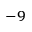<formula> <loc_0><loc_0><loc_500><loc_500>^ { - 9 }</formula> 